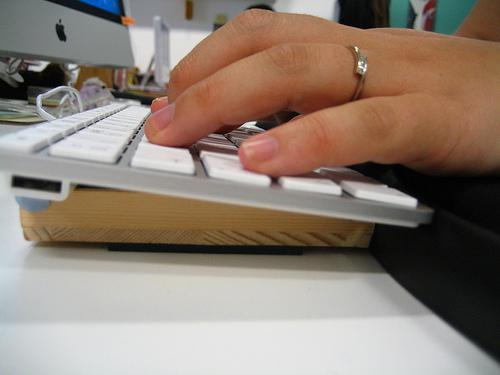Question: what hand has a ring on it?
Choices:
A. Left.
B. Right.
C. The wife's.
D. The husband's.
Answer with the letter. Answer: A Question: why is there an apple on the computer?
Choices:
A. Make.
B. Model.
C. The user is hungry.
D. Brand.
Answer with the letter. Answer: D Question: who is sitting in the chair?
Choices:
A. A man.
B. A cat.
C. A lady.
D. A girl.
Answer with the letter. Answer: C Question: how many computers are in this picture?
Choices:
A. 3.
B. 2.
C. 1.
D. 0.
Answer with the letter. Answer: B 